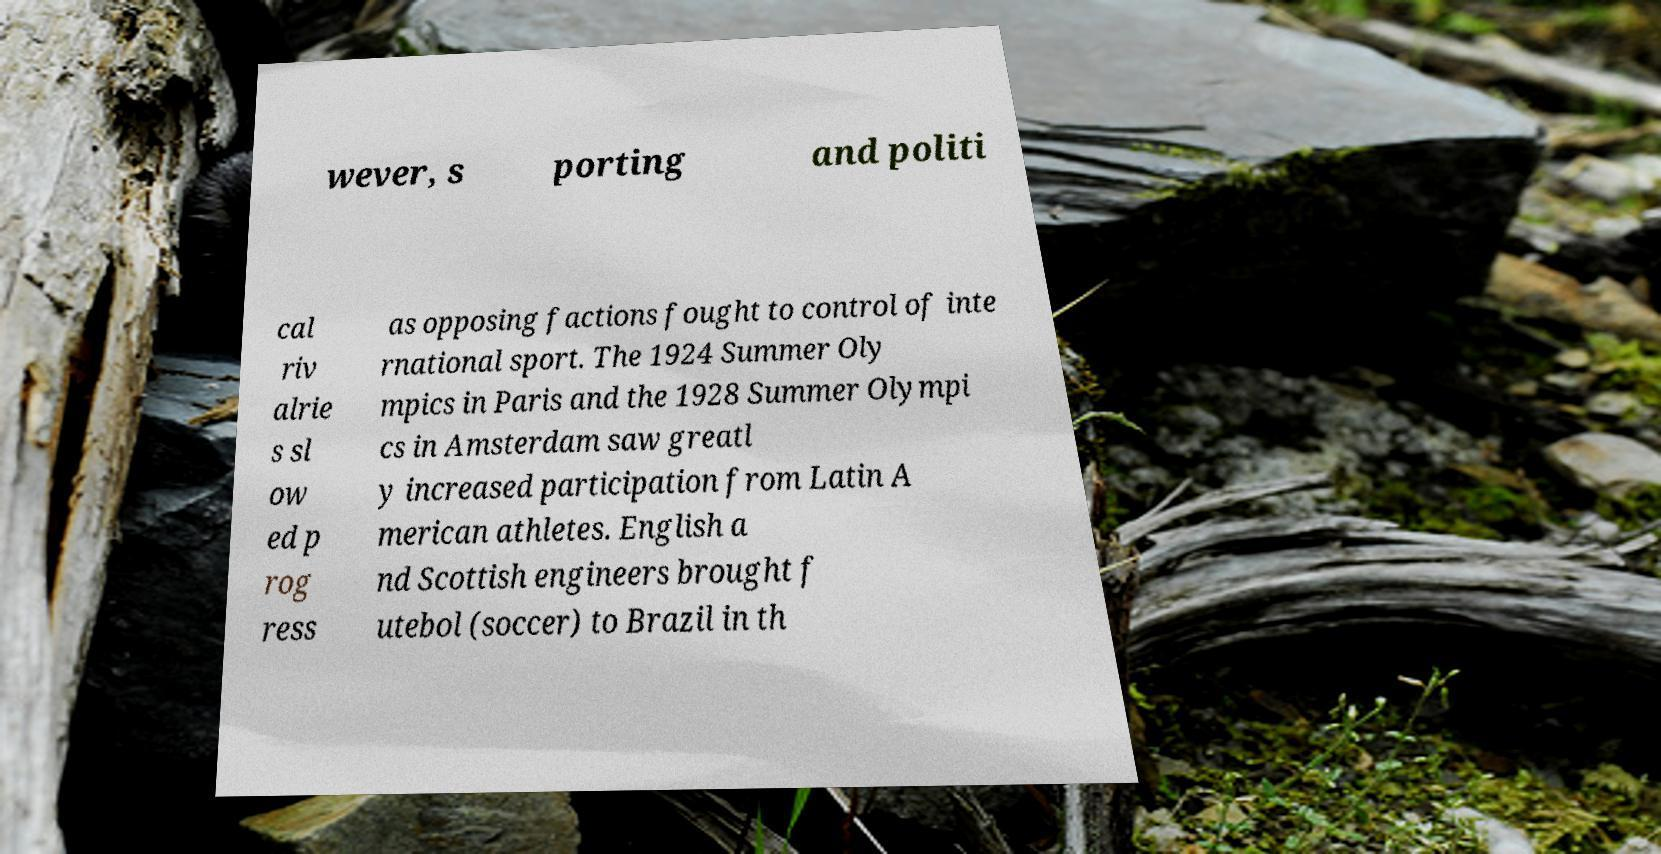What messages or text are displayed in this image? I need them in a readable, typed format. wever, s porting and politi cal riv alrie s sl ow ed p rog ress as opposing factions fought to control of inte rnational sport. The 1924 Summer Oly mpics in Paris and the 1928 Summer Olympi cs in Amsterdam saw greatl y increased participation from Latin A merican athletes. English a nd Scottish engineers brought f utebol (soccer) to Brazil in th 